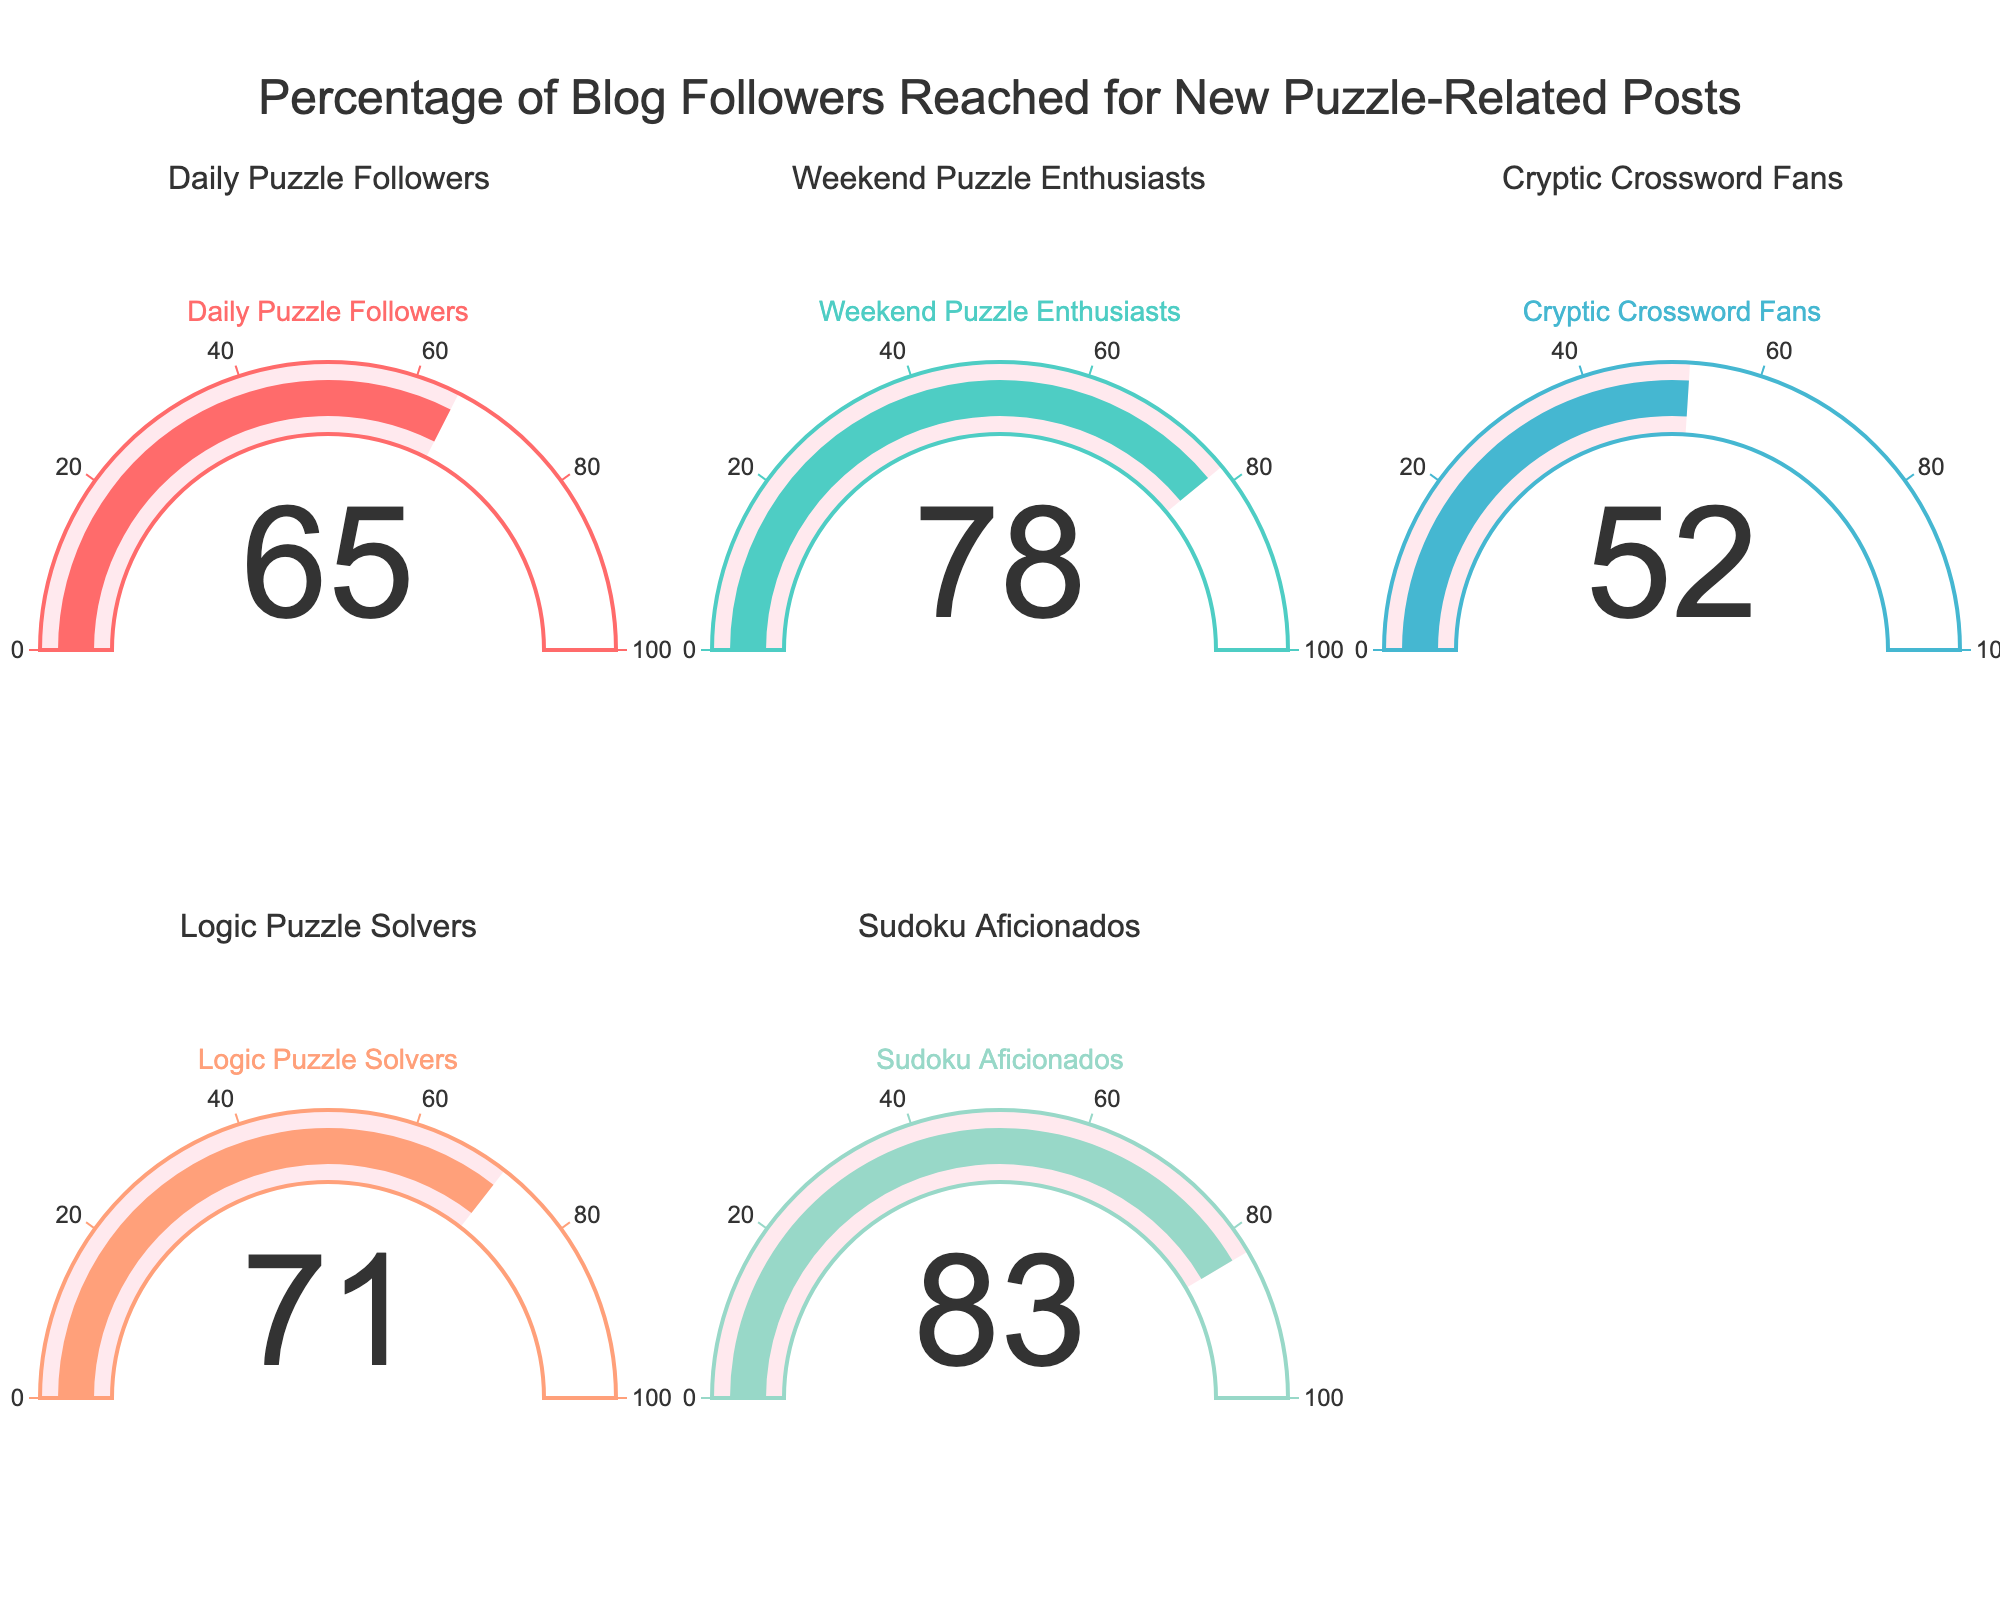Which follower group has the highest percentage reached? The highest percentage reached can be found by looking at the values displayed on the gauge charts and identifying the highest one among those. In this case, "Sudoku Aficionados" has the highest value of 83.
Answer: Sudoku Aficionados What is the total percentage of blog followers reached across all groups? To find the total percentage, sum the values of all the follower groups: 65 (Daily Puzzle Followers) + 78 (Weekend Puzzle Enthusiasts) + 52 (Cryptic Crossword Fans) + 71 (Logic Puzzle Solvers) + 83 (Sudoku Aficionados). This gives a total of 349.
Answer: 349 Which groups have a percentage reached above 70%? By inspecting the gauge charts, we look for values above 70%. These groups are "Weekend Puzzle Enthusiasts" (78), "Logic Puzzle Solvers" (71), and "Sudoku Aficionados" (83).
Answer: Weekend Puzzle Enthusiasts, Logic Puzzle Solvers, Sudoku Aficionados What's the difference between the highest and the lowest percentage reached? Identify the highest value (83 for Sudoku Aficionados) and the lowest value (52 for Cryptic Crossword Fans). Subtract the lowest value from the highest: 83 - 52 = 31.
Answer: 31 What is the average percentage reached by all follower groups? Sum the percentages: 65 + 78 + 52 + 71 + 83 = 349. Then divide by the number of groups (5): 349 / 5 = 69.8.
Answer: 69.8 Which follower group has the second lowest percentage reached? First, identify the percentages and sort them: 52, 65, 71, 78, 83. The second lowest percentage is 65, which corresponds to the "Daily Puzzle Followers."
Answer: Daily Puzzle Followers Are there more follower groups with percentages below 70% or above 70%? Identify groups below 70%: 65 (Daily Puzzle Followers), 52 (Cryptic Crossword Fans) — total 2. Identify groups above 70%: 78 (Weekend Puzzle Enthusiasts), 71 (Logic Puzzle Solvers), 83 (Sudoku Aficionados) — total 3. 3 groups are above 70% while 2 are below.
Answer: Above 70% What is the median percentage reached among the follower groups? Sort the percentages: 52, 65, 71, 78, 83. The median is the middle value, which is 71.
Answer: 71 How does the percentage reached by Logic Puzzle Solvers compare to Cryptic Crossword Fans? The percentage reached by Logic Puzzle Solvers is 71, while that for Cryptic Crossword Fans is 52. Hence, Logic Puzzle Solvers have a higher percentage.
Answer: Higher Which gauge color represents the "Daily Puzzle Followers" and what value does it show? The "Daily Puzzle Followers" gauge is represented by the first color on the chart, which can be identified as the red color. It shows a value of 65.
Answer: Red, 65 